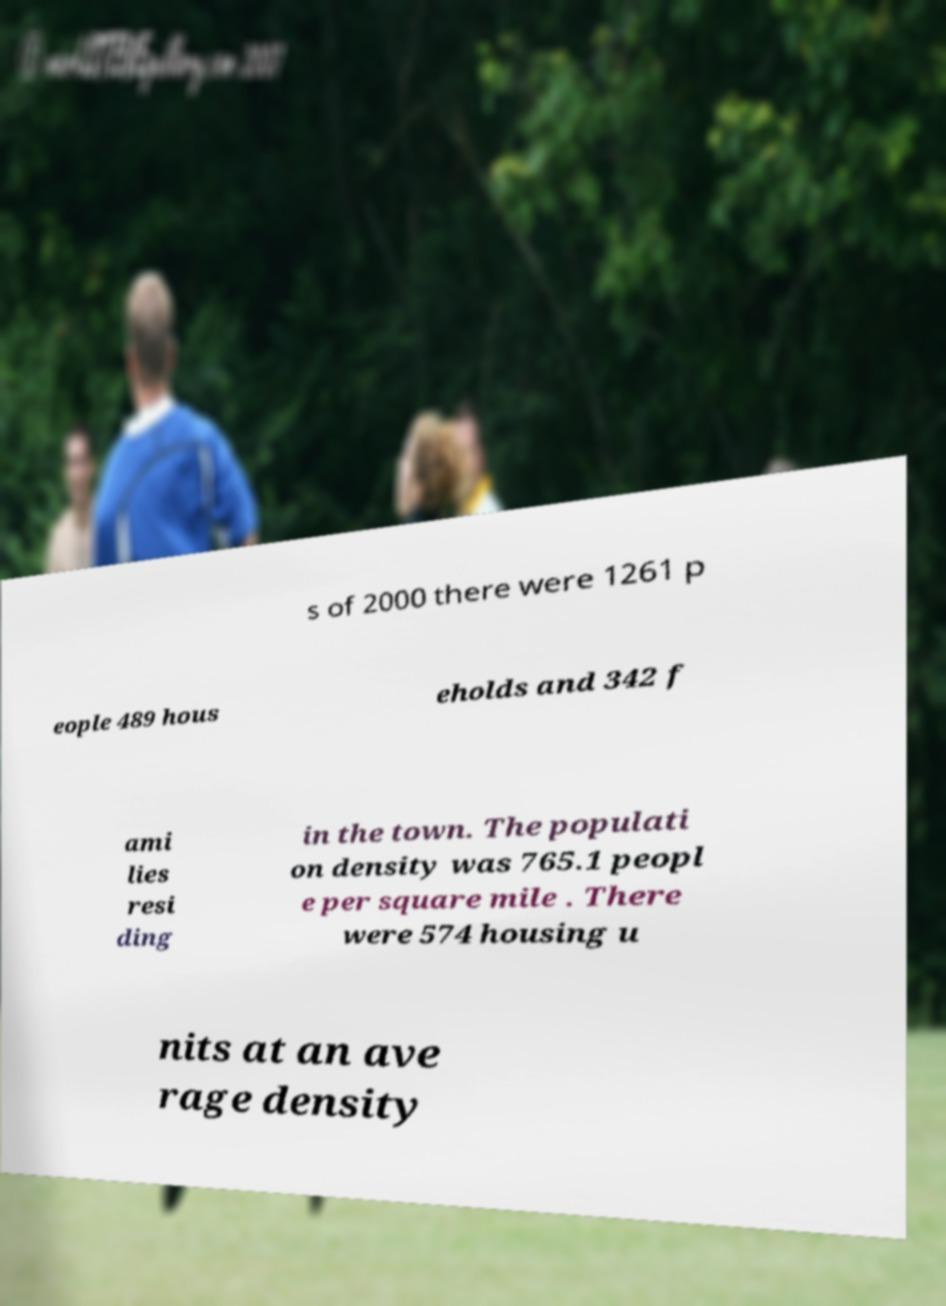What messages or text are displayed in this image? I need them in a readable, typed format. s of 2000 there were 1261 p eople 489 hous eholds and 342 f ami lies resi ding in the town. The populati on density was 765.1 peopl e per square mile . There were 574 housing u nits at an ave rage density 